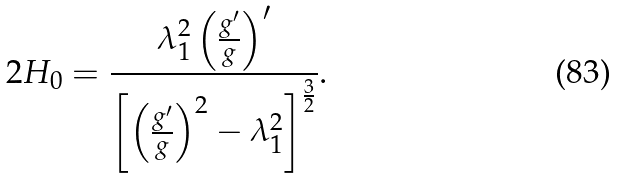Convert formula to latex. <formula><loc_0><loc_0><loc_500><loc_500>2 H _ { 0 } = \frac { \lambda _ { 1 } ^ { 2 } \left ( \frac { g ^ { \prime } } { g } \right ) ^ { \prime } } { \left [ \left ( \frac { g ^ { \prime } } { g } \right ) ^ { 2 } - \lambda _ { 1 } ^ { 2 } \right ] ^ { \frac { 3 } { 2 } } } .</formula> 